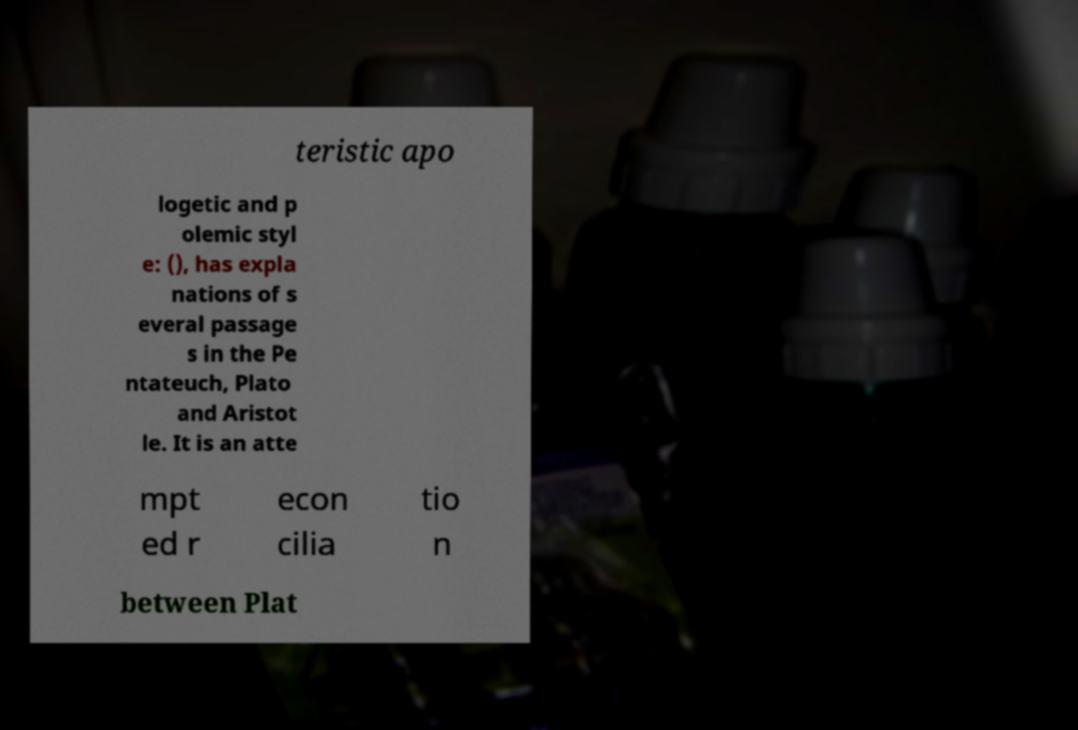I need the written content from this picture converted into text. Can you do that? teristic apo logetic and p olemic styl e: (), has expla nations of s everal passage s in the Pe ntateuch, Plato and Aristot le. It is an atte mpt ed r econ cilia tio n between Plat 